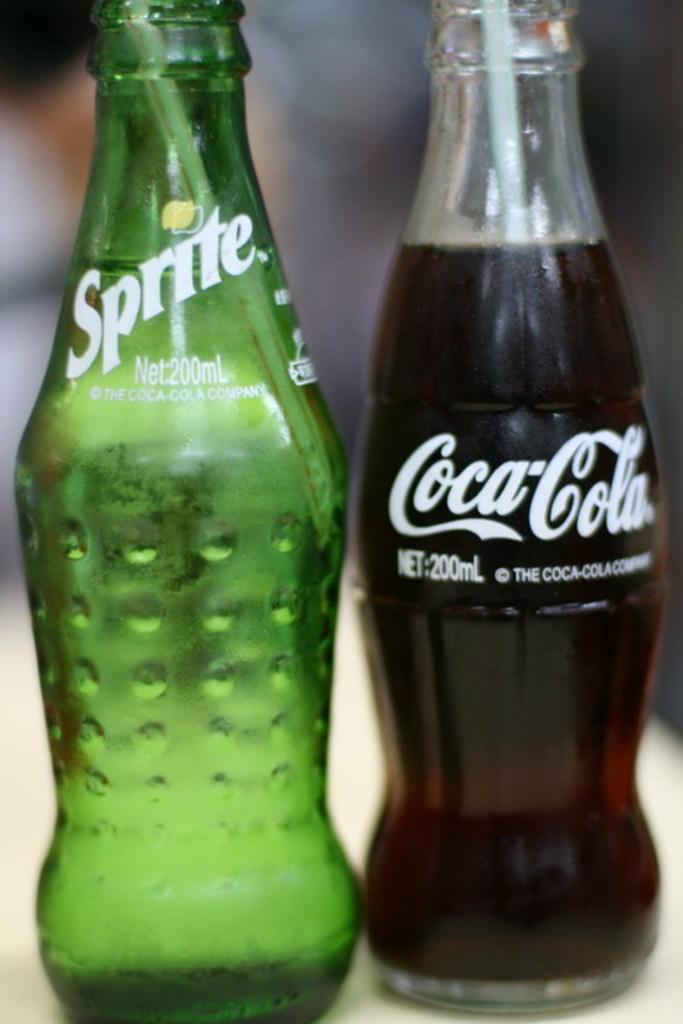How many glass bottles are visible in the image? There are two glass bottles in the image. What is the content of the first bottle? The first bottle contains Sprite. What is the content of the second bottle? The second bottle contains Coca Cola. What type of destruction can be seen happening to the bottles in the image? There is no destruction happening to the bottles in the image; they are both intact. 